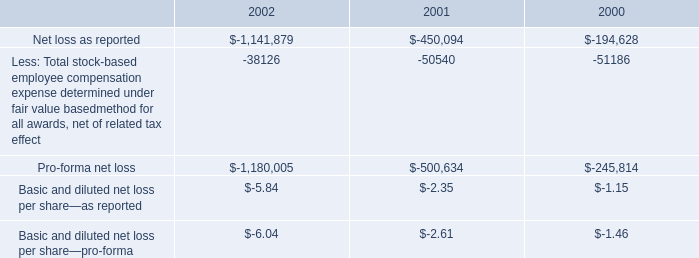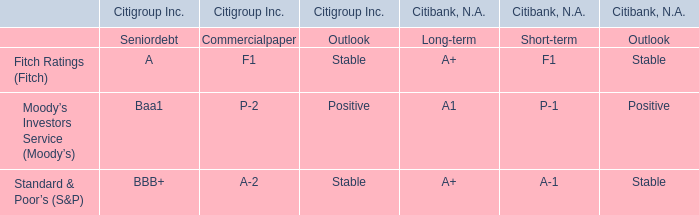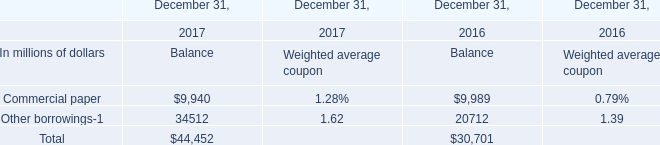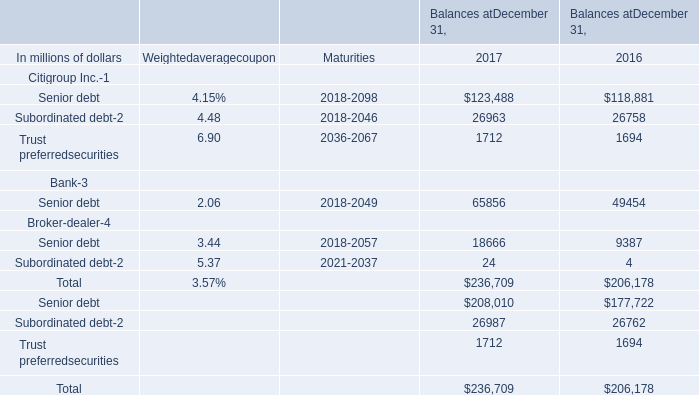Does the value of Senior debt for Citigroup Inc in 2016 greater than that in 2017? 
Answer: No. 